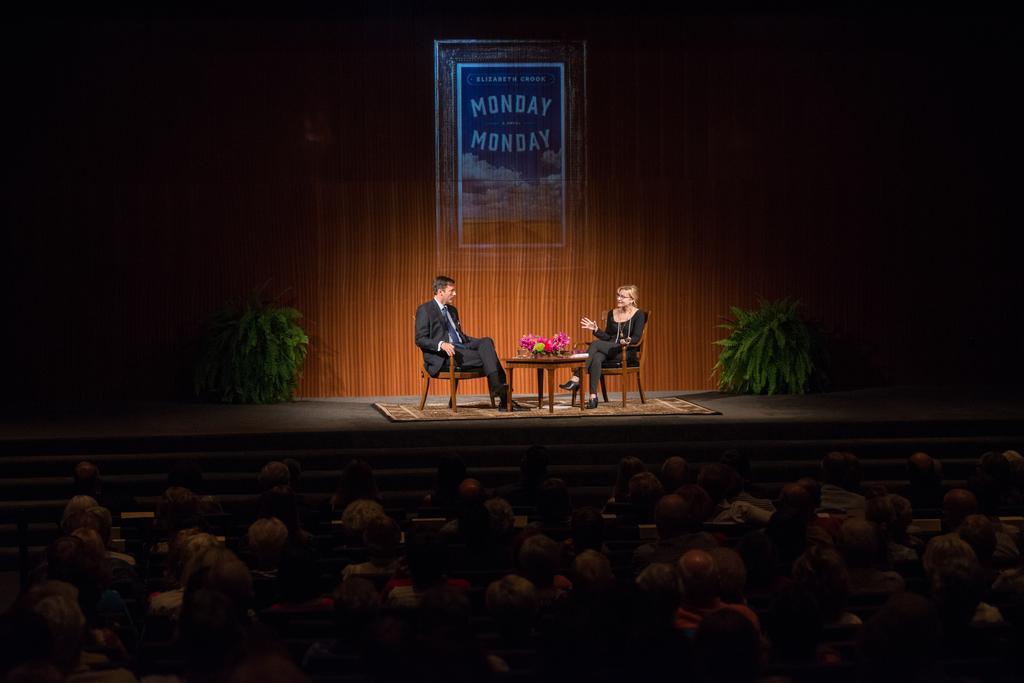How would you summarize this image in a sentence or two? In this picture there are two people sitting on the chairs and there is a flower vase on the table and there are plants and there is a mat on the stage. At the back there is a board and there is text on the board. In the foreground there are group of people sitting. 